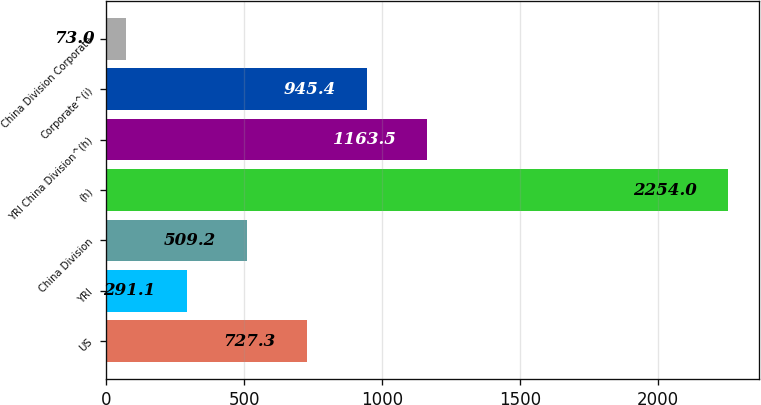<chart> <loc_0><loc_0><loc_500><loc_500><bar_chart><fcel>US<fcel>YRI<fcel>China Division<fcel>(h)<fcel>YRI China Division^(h)<fcel>Corporate^(i)<fcel>China Division Corporate<nl><fcel>727.3<fcel>291.1<fcel>509.2<fcel>2254<fcel>1163.5<fcel>945.4<fcel>73<nl></chart> 